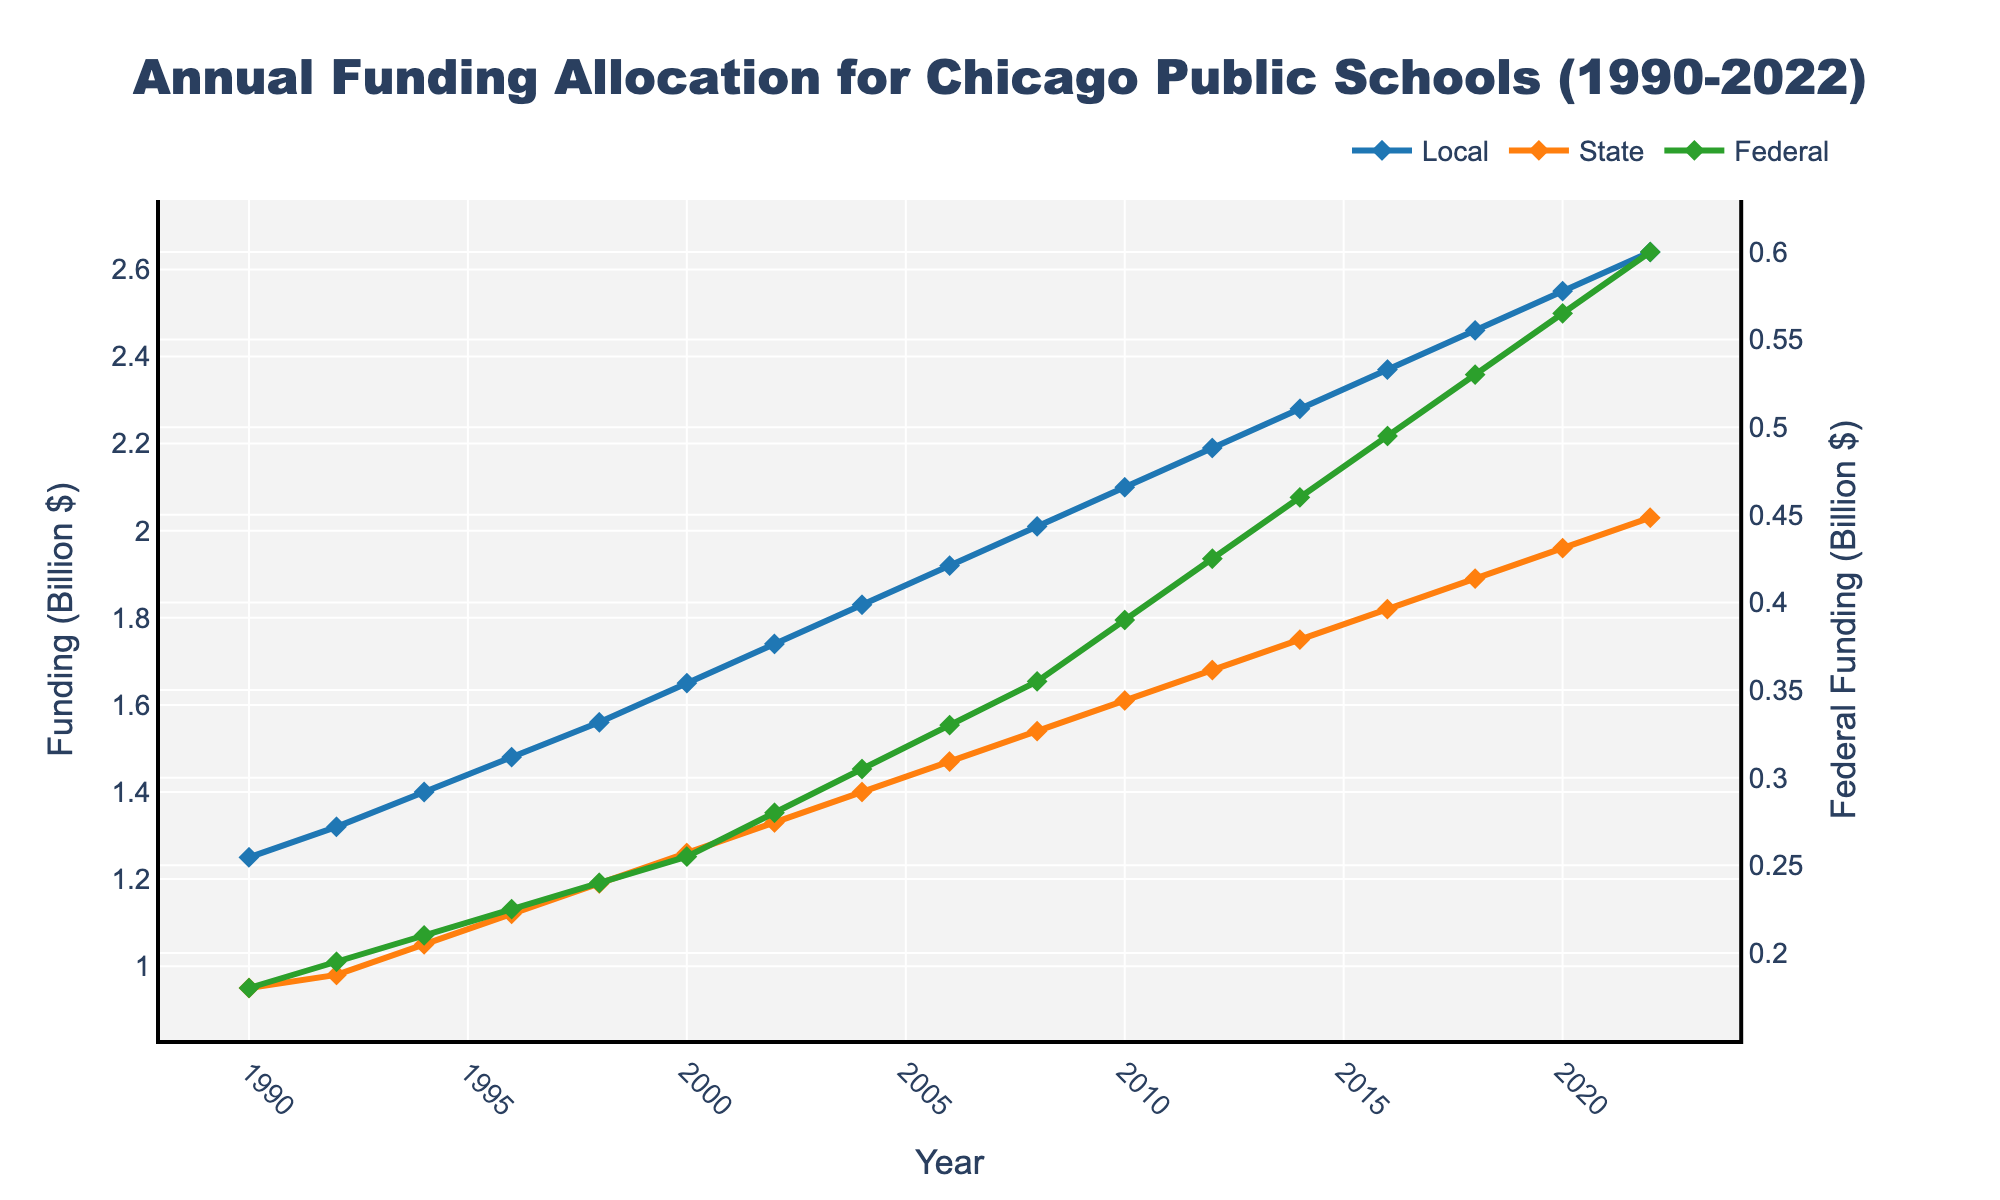What is the overall trend of local funding from 1990 to 2022? The overall trend of local funding from 1990 to 2022 is increasing. This is evident as each data point for local funding is higher than the previous one, indicating a consistent upward trend.
Answer: Increasing Which funding source had the highest value in 2000? In the year 2000, the local funding source has the highest value as the line representing local funding is at the top compared to the state and federal funding lines.
Answer: Local How much did state funding increase from 1990 to 2022? To find the increase in state funding from 1990 to 2022, subtract the 1990 value from the 2022 value. 2030 million (2022) - 950 million (1990) = 1080 million or 1.08 billion.
Answer: 1.08 billion What is the average annual federal funding from 1990 to 2022? Add federal funding values from 1990 to 2022 and divide by the number of years (2022-1990+1 = 33 years). The calculation is (180 + 195 + 210 + 225 + 240 + 255 + 280 + 305 + 330 + 355 + 390 + 425 + 460 + 495 + 530 + 565 + 600) / 33 = 393.18 million or 0.393 billion.
Answer: 0.393 billion In which year did local funding reach 2 billion dollars? Look for the year when the local funding category reaches 2 billion in the plot. This occurs in 2008.
Answer: 2008 Which funding source shows the most significant increase from 1990 to 2022 in absolute terms? Comparing the increases for each funding source: Local (2640-1250 = 1390 million), State (2030-950 = 1080 million), Federal (600-180 = 420 million), Local funding shows the most significant increase.
Answer: Local Were there any periods where federal funding remained constant for multiple consecutive years? By examining the federal funding line in the plot, we see that there are no periods where federal funding remains constant; it continuously increases.
Answer: No Which funding source has the steepest slope between 2016 and 2020? The slope can be estimated as the vertical change over the horizontal change. Local increases by 9 billion (2460 to 2550), State by 7 billion (1890 to 1960), and Federal by 3.5 billion (530 to 565). Hence, the steepest slope is for Local funding.
Answer: Local What is the combined funding from all sources in 2010? Sum the values of all three funding sources in 2010: Local (2100 million), State (1610 million), and Federal (390 million). 2100 + 1610 + 390 = 4100 million or 4.1 billion.
Answer: 4.1 billion How does the rate of increase of state funding compare to that of federal funding from 2010 to 2022? Calculate the rate of increase for both state and federal funding from 2010 to 2022. State: (2030-1610) / 12 = 35 million/year. Federal: (600-390)/12 = 17.5 million/year. The rate of increase of state funding is twice that of federal funding.
Answer: State funding increases at twice the rate 